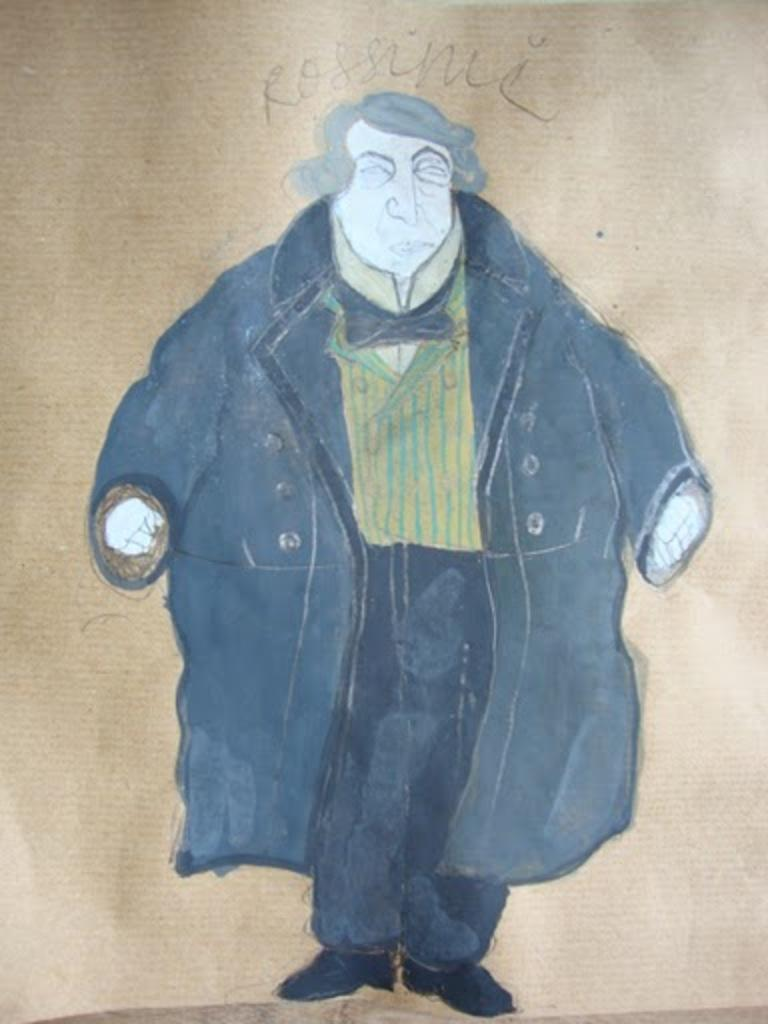What is depicted in the image? There is a painting of a man in the image. What is the man in the painting wearing? The man in the painting is wearing a jacket. What additional detail can be seen in the painting? There is text written on a mat above the man in the painting. Can you hear any songs being sung by the snail in the image? There is no snail present in the image, and therefore no singing can be heard. 